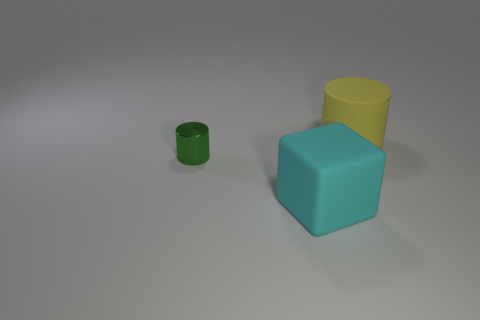What number of large objects are either cyan matte things or shiny cylinders?
Offer a terse response. 1. Is the number of small green things right of the cyan matte object the same as the number of big cubes in front of the large yellow matte object?
Offer a terse response. No. What number of other things are there of the same color as the matte cylinder?
Offer a terse response. 0. How many green objects are rubber objects or rubber cylinders?
Offer a very short reply. 0. Is the number of large rubber objects left of the matte block the same as the number of yellow matte balls?
Offer a very short reply. Yes. Is there anything else that is the same size as the metallic cylinder?
Make the answer very short. No. There is another thing that is the same shape as the big yellow object; what is its color?
Keep it short and to the point. Green. How many big objects are the same shape as the small green thing?
Keep it short and to the point. 1. How many big yellow matte objects are there?
Make the answer very short. 1. Is there a blue sphere made of the same material as the green cylinder?
Provide a succinct answer. No. 